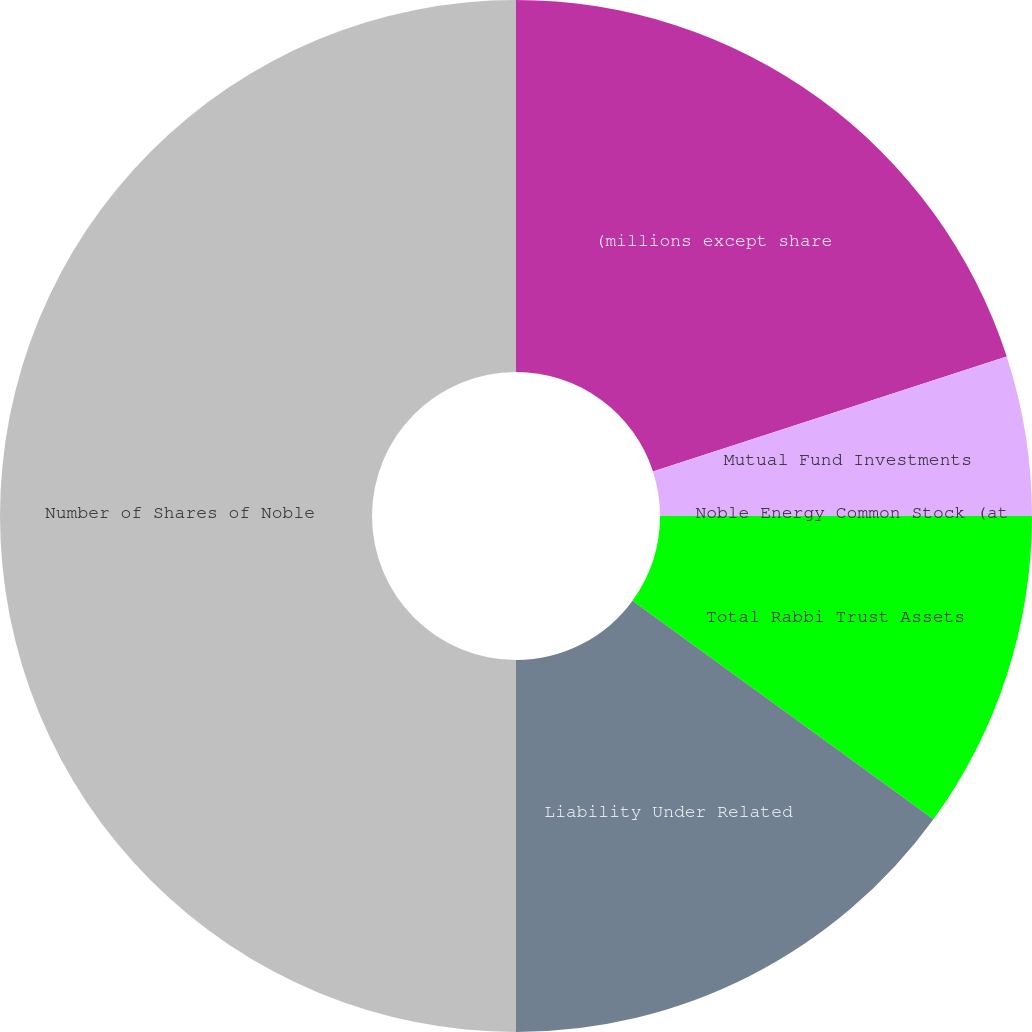Convert chart to OTSL. <chart><loc_0><loc_0><loc_500><loc_500><pie_chart><fcel>(millions except share<fcel>Mutual Fund Investments<fcel>Noble Energy Common Stock (at<fcel>Total Rabbi Trust Assets<fcel>Liability Under Related<fcel>Number of Shares of Noble<nl><fcel>20.0%<fcel>5.0%<fcel>0.0%<fcel>10.0%<fcel>15.0%<fcel>50.0%<nl></chart> 